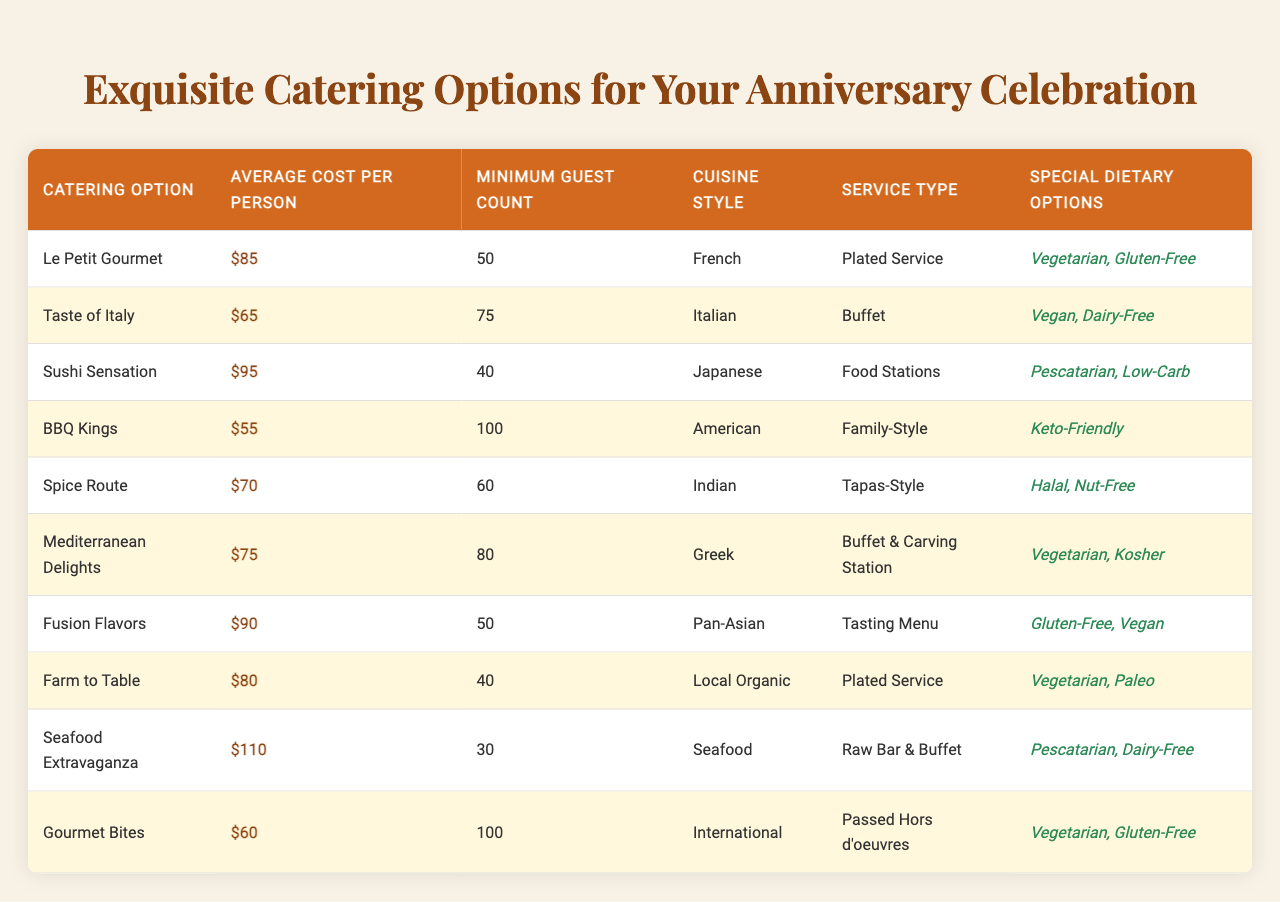What is the average cost per person for "Taste of Italy"? The table shows that "Taste of Italy" has an average cost per person of $65.
Answer: $65 Which catering option has the highest average cost per person? According to the table, "Seafood Extravaganza" has the highest average cost per person at $110.
Answer: $110 What is the minimum guest count for "Le Petit Gourmet"? From the table, "Le Petit Gourmet" requires a minimum guest count of 50.
Answer: 50 Is vegetarian option available in all catering options? The table shows that not all catering options have vegetarian choices; for example, "BBQ Kings" does not list it.
Answer: No What is the average minimum guest count for all catering options? The minimum guest counts are 50, 75, 40, 100, 60, 80, 50, 40, 30, and 100. Summing these gives 675, divided by 10 gives an average of 67.5.
Answer: 67.5 Which catering options provide special dietary options for Pescatarians? The table indicates "Sushi Sensation" and "Seafood Extravaganza" both offer special dietary options for Pescatarians.
Answer: Sushi Sensation, Seafood Extravaganza If I want to invite 80 guests, which catering options are available? The options available for a minimum of 80 guests in the table are "Taste of Italy," "Mediterranean Delights," and "BBQ Kings."
Answer: Taste of Italy, Mediterranean Delights, BBQ Kings What is the difference in average cost per person between "BBQ Kings" and "Le Petit Gourmet"? The average cost per person for "BBQ Kings" is $55; for "Le Petit Gourmet," it is $85. The difference is 85 - 55 = 30.
Answer: $30 How many catering options have a minimum guest count of 60 or more? The table lists "Taste of Italy," "BBQ Kings," "Mediterranean Delights," and "Gourmet Bites," summing up to four options meeting this criterion.
Answer: 4 Which cuisine style is associated with "Fusion Flavors"? The table specifies that "Fusion Flavors" is associated with the Pan-Asian cuisine style.
Answer: Pan-Asian Can you find a catering option that includes a family-style service type? The table shows that "BBQ Kings" offers a family-style service.
Answer: BBQ Kings 